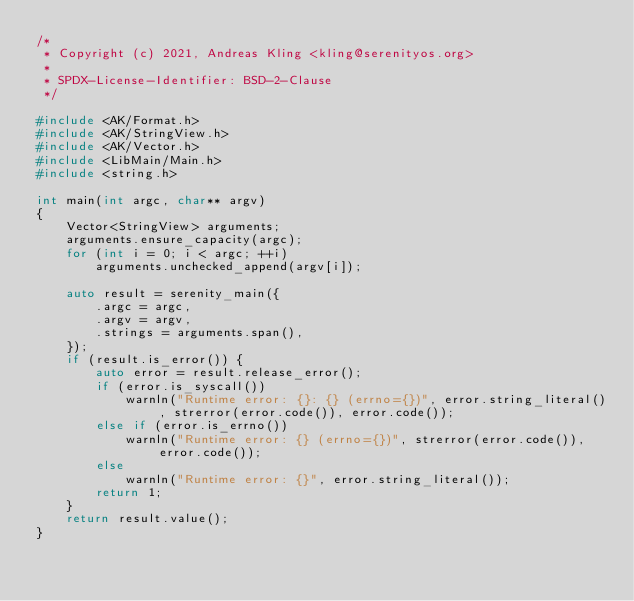<code> <loc_0><loc_0><loc_500><loc_500><_C++_>/*
 * Copyright (c) 2021, Andreas Kling <kling@serenityos.org>
 *
 * SPDX-License-Identifier: BSD-2-Clause
 */

#include <AK/Format.h>
#include <AK/StringView.h>
#include <AK/Vector.h>
#include <LibMain/Main.h>
#include <string.h>

int main(int argc, char** argv)
{
    Vector<StringView> arguments;
    arguments.ensure_capacity(argc);
    for (int i = 0; i < argc; ++i)
        arguments.unchecked_append(argv[i]);

    auto result = serenity_main({
        .argc = argc,
        .argv = argv,
        .strings = arguments.span(),
    });
    if (result.is_error()) {
        auto error = result.release_error();
        if (error.is_syscall())
            warnln("Runtime error: {}: {} (errno={})", error.string_literal(), strerror(error.code()), error.code());
        else if (error.is_errno())
            warnln("Runtime error: {} (errno={})", strerror(error.code()), error.code());
        else
            warnln("Runtime error: {}", error.string_literal());
        return 1;
    }
    return result.value();
}
</code> 